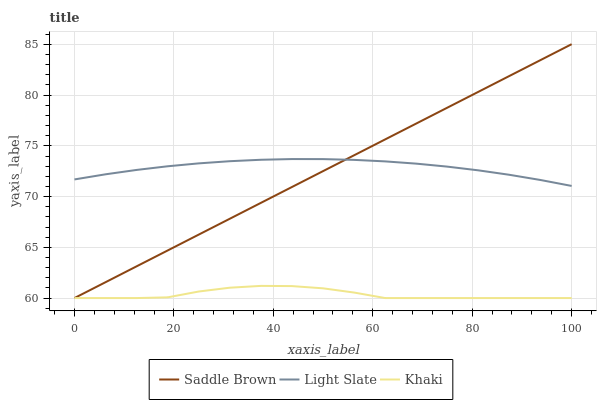Does Khaki have the minimum area under the curve?
Answer yes or no. Yes. Does Light Slate have the maximum area under the curve?
Answer yes or no. Yes. Does Saddle Brown have the minimum area under the curve?
Answer yes or no. No. Does Saddle Brown have the maximum area under the curve?
Answer yes or no. No. Is Saddle Brown the smoothest?
Answer yes or no. Yes. Is Khaki the roughest?
Answer yes or no. Yes. Is Khaki the smoothest?
Answer yes or no. No. Is Saddle Brown the roughest?
Answer yes or no. No. Does Saddle Brown have the highest value?
Answer yes or no. Yes. Does Khaki have the highest value?
Answer yes or no. No. Is Khaki less than Light Slate?
Answer yes or no. Yes. Is Light Slate greater than Khaki?
Answer yes or no. Yes. Does Saddle Brown intersect Light Slate?
Answer yes or no. Yes. Is Saddle Brown less than Light Slate?
Answer yes or no. No. Is Saddle Brown greater than Light Slate?
Answer yes or no. No. Does Khaki intersect Light Slate?
Answer yes or no. No. 